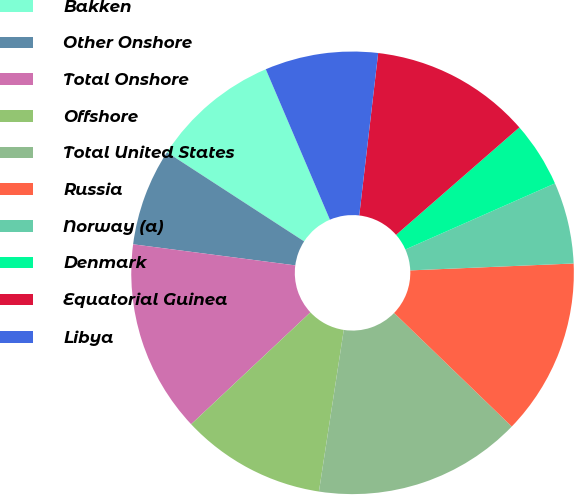<chart> <loc_0><loc_0><loc_500><loc_500><pie_chart><fcel>Bakken<fcel>Other Onshore<fcel>Total Onshore<fcel>Offshore<fcel>Total United States<fcel>Russia<fcel>Norway (a)<fcel>Denmark<fcel>Equatorial Guinea<fcel>Libya<nl><fcel>9.42%<fcel>7.11%<fcel>14.05%<fcel>10.58%<fcel>15.21%<fcel>12.89%<fcel>5.95%<fcel>4.79%<fcel>11.74%<fcel>8.26%<nl></chart> 